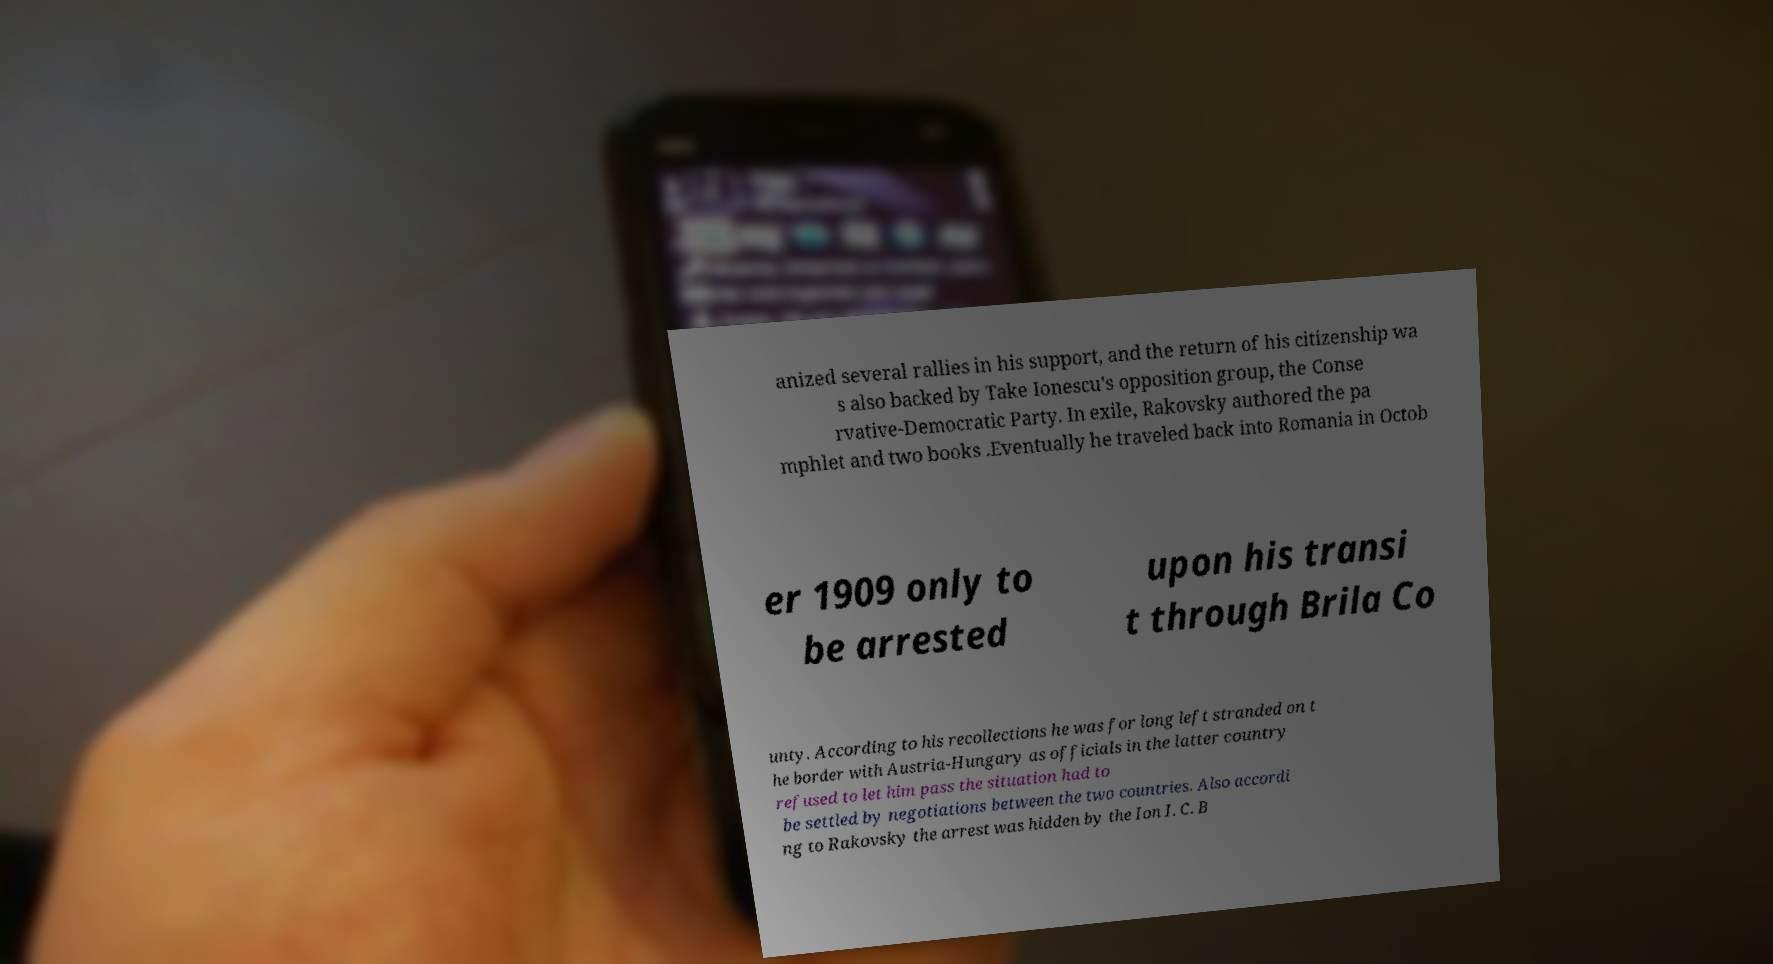Please identify and transcribe the text found in this image. anized several rallies in his support, and the return of his citizenship wa s also backed by Take Ionescu's opposition group, the Conse rvative-Democratic Party. In exile, Rakovsky authored the pa mphlet and two books .Eventually he traveled back into Romania in Octob er 1909 only to be arrested upon his transi t through Brila Co unty. According to his recollections he was for long left stranded on t he border with Austria-Hungary as officials in the latter country refused to let him pass the situation had to be settled by negotiations between the two countries. Also accordi ng to Rakovsky the arrest was hidden by the Ion I. C. B 